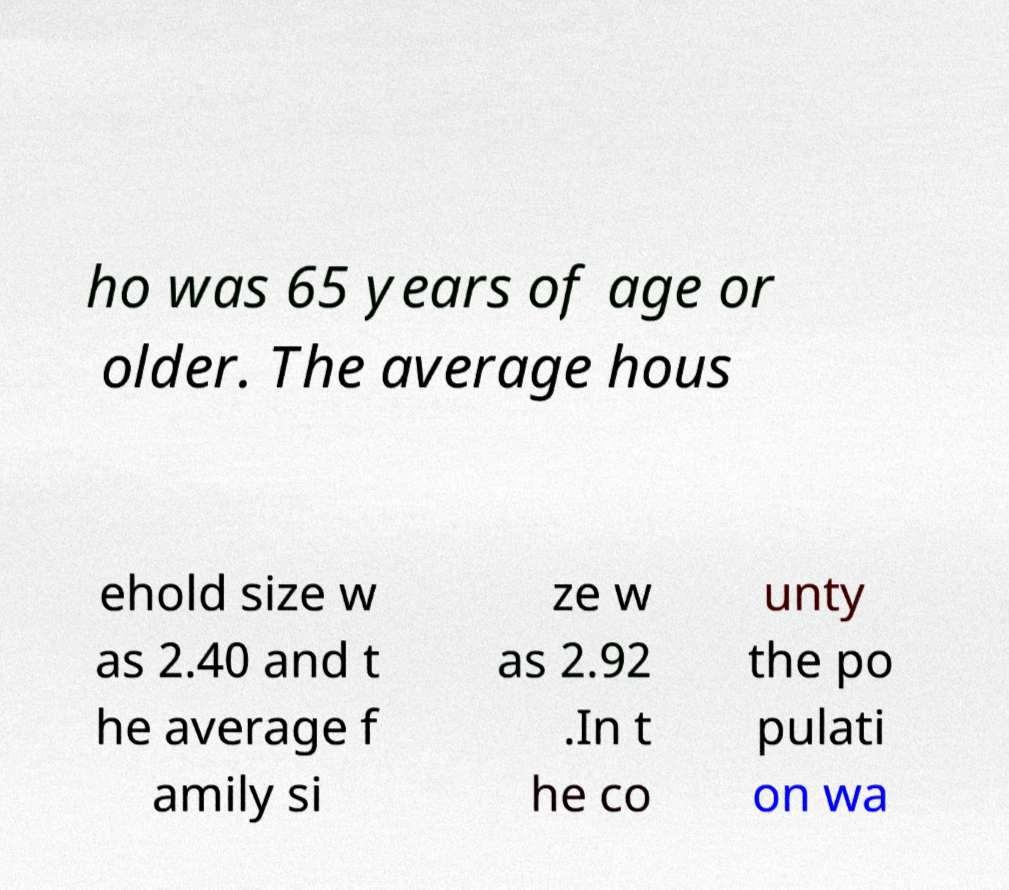What messages or text are displayed in this image? I need them in a readable, typed format. ho was 65 years of age or older. The average hous ehold size w as 2.40 and t he average f amily si ze w as 2.92 .In t he co unty the po pulati on wa 